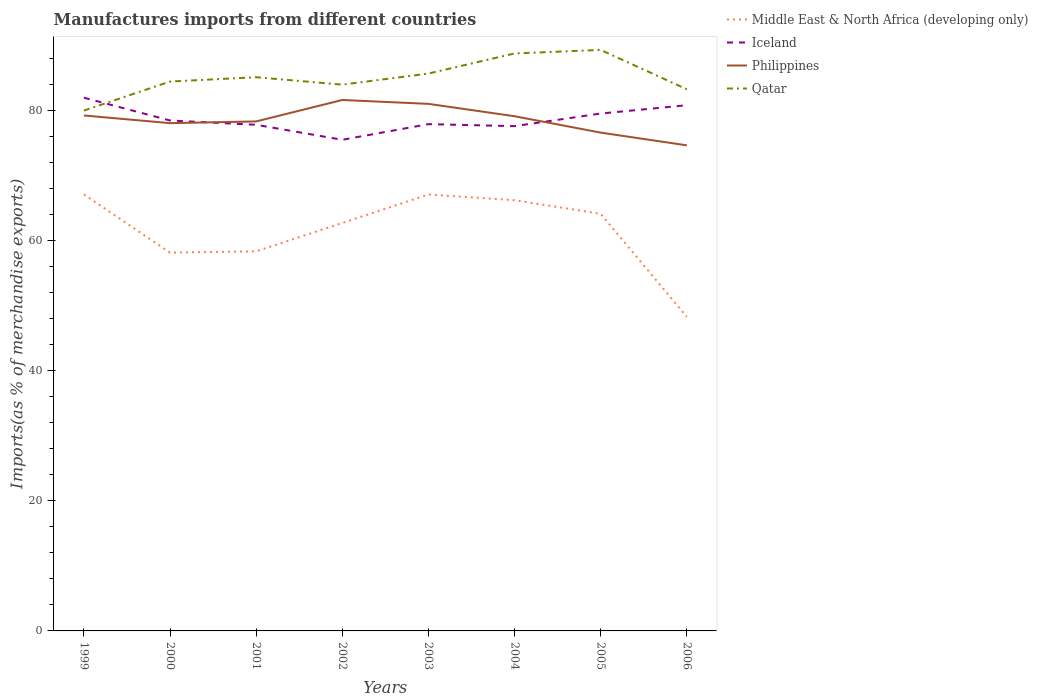Does the line corresponding to Iceland intersect with the line corresponding to Qatar?
Your answer should be compact. Yes. Is the number of lines equal to the number of legend labels?
Keep it short and to the point. Yes. Across all years, what is the maximum percentage of imports to different countries in Qatar?
Keep it short and to the point. 79.95. In which year was the percentage of imports to different countries in Philippines maximum?
Offer a very short reply. 2006. What is the total percentage of imports to different countries in Philippines in the graph?
Offer a very short reply. 4.59. What is the difference between the highest and the second highest percentage of imports to different countries in Philippines?
Your answer should be very brief. 6.97. Is the percentage of imports to different countries in Middle East & North Africa (developing only) strictly greater than the percentage of imports to different countries in Iceland over the years?
Offer a terse response. Yes. What is the difference between two consecutive major ticks on the Y-axis?
Make the answer very short. 20. Does the graph contain grids?
Offer a terse response. No. Where does the legend appear in the graph?
Your answer should be very brief. Top right. How are the legend labels stacked?
Make the answer very short. Vertical. What is the title of the graph?
Provide a succinct answer. Manufactures imports from different countries. Does "Central African Republic" appear as one of the legend labels in the graph?
Your answer should be very brief. No. What is the label or title of the Y-axis?
Your answer should be very brief. Imports(as % of merchandise exports). What is the Imports(as % of merchandise exports) of Middle East & North Africa (developing only) in 1999?
Ensure brevity in your answer.  67.07. What is the Imports(as % of merchandise exports) of Iceland in 1999?
Your answer should be compact. 81.93. What is the Imports(as % of merchandise exports) of Philippines in 1999?
Give a very brief answer. 79.2. What is the Imports(as % of merchandise exports) of Qatar in 1999?
Give a very brief answer. 79.95. What is the Imports(as % of merchandise exports) in Middle East & North Africa (developing only) in 2000?
Keep it short and to the point. 58.12. What is the Imports(as % of merchandise exports) in Iceland in 2000?
Provide a short and direct response. 78.42. What is the Imports(as % of merchandise exports) of Philippines in 2000?
Keep it short and to the point. 78.01. What is the Imports(as % of merchandise exports) in Qatar in 2000?
Provide a succinct answer. 84.41. What is the Imports(as % of merchandise exports) of Middle East & North Africa (developing only) in 2001?
Your answer should be compact. 58.32. What is the Imports(as % of merchandise exports) of Iceland in 2001?
Your answer should be compact. 77.76. What is the Imports(as % of merchandise exports) of Philippines in 2001?
Offer a very short reply. 78.28. What is the Imports(as % of merchandise exports) in Qatar in 2001?
Offer a terse response. 85.07. What is the Imports(as % of merchandise exports) of Middle East & North Africa (developing only) in 2002?
Provide a short and direct response. 62.68. What is the Imports(as % of merchandise exports) in Iceland in 2002?
Make the answer very short. 75.46. What is the Imports(as % of merchandise exports) in Philippines in 2002?
Offer a terse response. 81.57. What is the Imports(as % of merchandise exports) in Qatar in 2002?
Your response must be concise. 83.93. What is the Imports(as % of merchandise exports) in Middle East & North Africa (developing only) in 2003?
Ensure brevity in your answer.  67.05. What is the Imports(as % of merchandise exports) in Iceland in 2003?
Keep it short and to the point. 77.86. What is the Imports(as % of merchandise exports) of Philippines in 2003?
Offer a terse response. 80.98. What is the Imports(as % of merchandise exports) of Qatar in 2003?
Ensure brevity in your answer.  85.64. What is the Imports(as % of merchandise exports) in Middle East & North Africa (developing only) in 2004?
Provide a short and direct response. 66.18. What is the Imports(as % of merchandise exports) in Iceland in 2004?
Ensure brevity in your answer.  77.56. What is the Imports(as % of merchandise exports) of Philippines in 2004?
Keep it short and to the point. 79.07. What is the Imports(as % of merchandise exports) in Qatar in 2004?
Offer a very short reply. 88.72. What is the Imports(as % of merchandise exports) in Middle East & North Africa (developing only) in 2005?
Provide a succinct answer. 64.08. What is the Imports(as % of merchandise exports) in Iceland in 2005?
Give a very brief answer. 79.49. What is the Imports(as % of merchandise exports) of Philippines in 2005?
Your answer should be very brief. 76.56. What is the Imports(as % of merchandise exports) of Qatar in 2005?
Your response must be concise. 89.27. What is the Imports(as % of merchandise exports) of Middle East & North Africa (developing only) in 2006?
Ensure brevity in your answer.  48.25. What is the Imports(as % of merchandise exports) in Iceland in 2006?
Your answer should be very brief. 80.77. What is the Imports(as % of merchandise exports) in Philippines in 2006?
Your answer should be very brief. 74.6. What is the Imports(as % of merchandise exports) in Qatar in 2006?
Make the answer very short. 83.21. Across all years, what is the maximum Imports(as % of merchandise exports) in Middle East & North Africa (developing only)?
Your answer should be very brief. 67.07. Across all years, what is the maximum Imports(as % of merchandise exports) of Iceland?
Provide a short and direct response. 81.93. Across all years, what is the maximum Imports(as % of merchandise exports) of Philippines?
Provide a short and direct response. 81.57. Across all years, what is the maximum Imports(as % of merchandise exports) in Qatar?
Give a very brief answer. 89.27. Across all years, what is the minimum Imports(as % of merchandise exports) of Middle East & North Africa (developing only)?
Offer a very short reply. 48.25. Across all years, what is the minimum Imports(as % of merchandise exports) in Iceland?
Keep it short and to the point. 75.46. Across all years, what is the minimum Imports(as % of merchandise exports) of Philippines?
Your response must be concise. 74.6. Across all years, what is the minimum Imports(as % of merchandise exports) in Qatar?
Keep it short and to the point. 79.95. What is the total Imports(as % of merchandise exports) in Middle East & North Africa (developing only) in the graph?
Give a very brief answer. 491.75. What is the total Imports(as % of merchandise exports) in Iceland in the graph?
Your answer should be compact. 629.25. What is the total Imports(as % of merchandise exports) in Philippines in the graph?
Your answer should be compact. 628.28. What is the total Imports(as % of merchandise exports) in Qatar in the graph?
Ensure brevity in your answer.  680.19. What is the difference between the Imports(as % of merchandise exports) of Middle East & North Africa (developing only) in 1999 and that in 2000?
Provide a short and direct response. 8.95. What is the difference between the Imports(as % of merchandise exports) in Iceland in 1999 and that in 2000?
Make the answer very short. 3.5. What is the difference between the Imports(as % of merchandise exports) in Philippines in 1999 and that in 2000?
Ensure brevity in your answer.  1.18. What is the difference between the Imports(as % of merchandise exports) in Qatar in 1999 and that in 2000?
Keep it short and to the point. -4.46. What is the difference between the Imports(as % of merchandise exports) of Middle East & North Africa (developing only) in 1999 and that in 2001?
Your answer should be very brief. 8.75. What is the difference between the Imports(as % of merchandise exports) in Iceland in 1999 and that in 2001?
Give a very brief answer. 4.16. What is the difference between the Imports(as % of merchandise exports) in Philippines in 1999 and that in 2001?
Ensure brevity in your answer.  0.92. What is the difference between the Imports(as % of merchandise exports) in Qatar in 1999 and that in 2001?
Provide a short and direct response. -5.13. What is the difference between the Imports(as % of merchandise exports) of Middle East & North Africa (developing only) in 1999 and that in 2002?
Offer a terse response. 4.4. What is the difference between the Imports(as % of merchandise exports) in Iceland in 1999 and that in 2002?
Your answer should be compact. 6.47. What is the difference between the Imports(as % of merchandise exports) of Philippines in 1999 and that in 2002?
Provide a succinct answer. -2.38. What is the difference between the Imports(as % of merchandise exports) in Qatar in 1999 and that in 2002?
Keep it short and to the point. -3.99. What is the difference between the Imports(as % of merchandise exports) in Middle East & North Africa (developing only) in 1999 and that in 2003?
Provide a succinct answer. 0.02. What is the difference between the Imports(as % of merchandise exports) of Iceland in 1999 and that in 2003?
Keep it short and to the point. 4.07. What is the difference between the Imports(as % of merchandise exports) of Philippines in 1999 and that in 2003?
Give a very brief answer. -1.78. What is the difference between the Imports(as % of merchandise exports) of Qatar in 1999 and that in 2003?
Your answer should be compact. -5.69. What is the difference between the Imports(as % of merchandise exports) in Middle East & North Africa (developing only) in 1999 and that in 2004?
Offer a very short reply. 0.89. What is the difference between the Imports(as % of merchandise exports) in Iceland in 1999 and that in 2004?
Your answer should be very brief. 4.37. What is the difference between the Imports(as % of merchandise exports) in Philippines in 1999 and that in 2004?
Keep it short and to the point. 0.12. What is the difference between the Imports(as % of merchandise exports) of Qatar in 1999 and that in 2004?
Provide a succinct answer. -8.78. What is the difference between the Imports(as % of merchandise exports) in Middle East & North Africa (developing only) in 1999 and that in 2005?
Your response must be concise. 2.99. What is the difference between the Imports(as % of merchandise exports) of Iceland in 1999 and that in 2005?
Offer a terse response. 2.44. What is the difference between the Imports(as % of merchandise exports) of Philippines in 1999 and that in 2005?
Ensure brevity in your answer.  2.64. What is the difference between the Imports(as % of merchandise exports) of Qatar in 1999 and that in 2005?
Keep it short and to the point. -9.32. What is the difference between the Imports(as % of merchandise exports) in Middle East & North Africa (developing only) in 1999 and that in 2006?
Provide a short and direct response. 18.82. What is the difference between the Imports(as % of merchandise exports) of Iceland in 1999 and that in 2006?
Provide a short and direct response. 1.16. What is the difference between the Imports(as % of merchandise exports) of Philippines in 1999 and that in 2006?
Provide a succinct answer. 4.59. What is the difference between the Imports(as % of merchandise exports) in Qatar in 1999 and that in 2006?
Provide a succinct answer. -3.27. What is the difference between the Imports(as % of merchandise exports) in Middle East & North Africa (developing only) in 2000 and that in 2001?
Offer a very short reply. -0.2. What is the difference between the Imports(as % of merchandise exports) in Iceland in 2000 and that in 2001?
Offer a terse response. 0.66. What is the difference between the Imports(as % of merchandise exports) of Philippines in 2000 and that in 2001?
Offer a terse response. -0.27. What is the difference between the Imports(as % of merchandise exports) of Qatar in 2000 and that in 2001?
Offer a very short reply. -0.67. What is the difference between the Imports(as % of merchandise exports) in Middle East & North Africa (developing only) in 2000 and that in 2002?
Your answer should be compact. -4.56. What is the difference between the Imports(as % of merchandise exports) in Iceland in 2000 and that in 2002?
Your answer should be very brief. 2.97. What is the difference between the Imports(as % of merchandise exports) of Philippines in 2000 and that in 2002?
Your answer should be very brief. -3.56. What is the difference between the Imports(as % of merchandise exports) of Qatar in 2000 and that in 2002?
Give a very brief answer. 0.48. What is the difference between the Imports(as % of merchandise exports) in Middle East & North Africa (developing only) in 2000 and that in 2003?
Ensure brevity in your answer.  -8.93. What is the difference between the Imports(as % of merchandise exports) in Iceland in 2000 and that in 2003?
Provide a succinct answer. 0.56. What is the difference between the Imports(as % of merchandise exports) of Philippines in 2000 and that in 2003?
Ensure brevity in your answer.  -2.97. What is the difference between the Imports(as % of merchandise exports) in Qatar in 2000 and that in 2003?
Make the answer very short. -1.23. What is the difference between the Imports(as % of merchandise exports) of Middle East & North Africa (developing only) in 2000 and that in 2004?
Make the answer very short. -8.06. What is the difference between the Imports(as % of merchandise exports) of Iceland in 2000 and that in 2004?
Your answer should be very brief. 0.87. What is the difference between the Imports(as % of merchandise exports) in Philippines in 2000 and that in 2004?
Ensure brevity in your answer.  -1.06. What is the difference between the Imports(as % of merchandise exports) in Qatar in 2000 and that in 2004?
Your answer should be very brief. -4.32. What is the difference between the Imports(as % of merchandise exports) of Middle East & North Africa (developing only) in 2000 and that in 2005?
Your answer should be very brief. -5.96. What is the difference between the Imports(as % of merchandise exports) in Iceland in 2000 and that in 2005?
Keep it short and to the point. -1.07. What is the difference between the Imports(as % of merchandise exports) of Philippines in 2000 and that in 2005?
Your answer should be compact. 1.45. What is the difference between the Imports(as % of merchandise exports) of Qatar in 2000 and that in 2005?
Your answer should be compact. -4.86. What is the difference between the Imports(as % of merchandise exports) in Middle East & North Africa (developing only) in 2000 and that in 2006?
Offer a terse response. 9.87. What is the difference between the Imports(as % of merchandise exports) in Iceland in 2000 and that in 2006?
Give a very brief answer. -2.35. What is the difference between the Imports(as % of merchandise exports) of Philippines in 2000 and that in 2006?
Your response must be concise. 3.41. What is the difference between the Imports(as % of merchandise exports) in Qatar in 2000 and that in 2006?
Your answer should be very brief. 1.19. What is the difference between the Imports(as % of merchandise exports) of Middle East & North Africa (developing only) in 2001 and that in 2002?
Give a very brief answer. -4.35. What is the difference between the Imports(as % of merchandise exports) of Iceland in 2001 and that in 2002?
Your response must be concise. 2.3. What is the difference between the Imports(as % of merchandise exports) in Philippines in 2001 and that in 2002?
Give a very brief answer. -3.29. What is the difference between the Imports(as % of merchandise exports) of Qatar in 2001 and that in 2002?
Provide a succinct answer. 1.14. What is the difference between the Imports(as % of merchandise exports) of Middle East & North Africa (developing only) in 2001 and that in 2003?
Offer a very short reply. -8.73. What is the difference between the Imports(as % of merchandise exports) in Iceland in 2001 and that in 2003?
Offer a terse response. -0.1. What is the difference between the Imports(as % of merchandise exports) in Philippines in 2001 and that in 2003?
Provide a short and direct response. -2.7. What is the difference between the Imports(as % of merchandise exports) of Qatar in 2001 and that in 2003?
Provide a short and direct response. -0.56. What is the difference between the Imports(as % of merchandise exports) of Middle East & North Africa (developing only) in 2001 and that in 2004?
Your answer should be compact. -7.86. What is the difference between the Imports(as % of merchandise exports) in Iceland in 2001 and that in 2004?
Keep it short and to the point. 0.21. What is the difference between the Imports(as % of merchandise exports) of Philippines in 2001 and that in 2004?
Your response must be concise. -0.79. What is the difference between the Imports(as % of merchandise exports) of Qatar in 2001 and that in 2004?
Offer a very short reply. -3.65. What is the difference between the Imports(as % of merchandise exports) in Middle East & North Africa (developing only) in 2001 and that in 2005?
Your answer should be compact. -5.76. What is the difference between the Imports(as % of merchandise exports) in Iceland in 2001 and that in 2005?
Your response must be concise. -1.73. What is the difference between the Imports(as % of merchandise exports) of Philippines in 2001 and that in 2005?
Provide a short and direct response. 1.72. What is the difference between the Imports(as % of merchandise exports) of Qatar in 2001 and that in 2005?
Offer a terse response. -4.19. What is the difference between the Imports(as % of merchandise exports) of Middle East & North Africa (developing only) in 2001 and that in 2006?
Give a very brief answer. 10.07. What is the difference between the Imports(as % of merchandise exports) in Iceland in 2001 and that in 2006?
Your response must be concise. -3.01. What is the difference between the Imports(as % of merchandise exports) in Philippines in 2001 and that in 2006?
Make the answer very short. 3.68. What is the difference between the Imports(as % of merchandise exports) of Qatar in 2001 and that in 2006?
Offer a very short reply. 1.86. What is the difference between the Imports(as % of merchandise exports) in Middle East & North Africa (developing only) in 2002 and that in 2003?
Make the answer very short. -4.37. What is the difference between the Imports(as % of merchandise exports) in Iceland in 2002 and that in 2003?
Keep it short and to the point. -2.4. What is the difference between the Imports(as % of merchandise exports) in Philippines in 2002 and that in 2003?
Keep it short and to the point. 0.59. What is the difference between the Imports(as % of merchandise exports) of Qatar in 2002 and that in 2003?
Your answer should be very brief. -1.7. What is the difference between the Imports(as % of merchandise exports) in Middle East & North Africa (developing only) in 2002 and that in 2004?
Make the answer very short. -3.5. What is the difference between the Imports(as % of merchandise exports) of Iceland in 2002 and that in 2004?
Offer a very short reply. -2.1. What is the difference between the Imports(as % of merchandise exports) of Philippines in 2002 and that in 2004?
Your answer should be compact. 2.5. What is the difference between the Imports(as % of merchandise exports) in Qatar in 2002 and that in 2004?
Your answer should be very brief. -4.79. What is the difference between the Imports(as % of merchandise exports) in Middle East & North Africa (developing only) in 2002 and that in 2005?
Provide a succinct answer. -1.41. What is the difference between the Imports(as % of merchandise exports) of Iceland in 2002 and that in 2005?
Your answer should be compact. -4.03. What is the difference between the Imports(as % of merchandise exports) of Philippines in 2002 and that in 2005?
Provide a short and direct response. 5.01. What is the difference between the Imports(as % of merchandise exports) in Qatar in 2002 and that in 2005?
Ensure brevity in your answer.  -5.33. What is the difference between the Imports(as % of merchandise exports) in Middle East & North Africa (developing only) in 2002 and that in 2006?
Keep it short and to the point. 14.42. What is the difference between the Imports(as % of merchandise exports) of Iceland in 2002 and that in 2006?
Offer a very short reply. -5.31. What is the difference between the Imports(as % of merchandise exports) in Philippines in 2002 and that in 2006?
Offer a terse response. 6.97. What is the difference between the Imports(as % of merchandise exports) in Qatar in 2002 and that in 2006?
Your answer should be compact. 0.72. What is the difference between the Imports(as % of merchandise exports) in Middle East & North Africa (developing only) in 2003 and that in 2004?
Your answer should be very brief. 0.87. What is the difference between the Imports(as % of merchandise exports) of Iceland in 2003 and that in 2004?
Your response must be concise. 0.31. What is the difference between the Imports(as % of merchandise exports) of Philippines in 2003 and that in 2004?
Your answer should be compact. 1.9. What is the difference between the Imports(as % of merchandise exports) of Qatar in 2003 and that in 2004?
Keep it short and to the point. -3.09. What is the difference between the Imports(as % of merchandise exports) of Middle East & North Africa (developing only) in 2003 and that in 2005?
Your answer should be compact. 2.97. What is the difference between the Imports(as % of merchandise exports) in Iceland in 2003 and that in 2005?
Ensure brevity in your answer.  -1.63. What is the difference between the Imports(as % of merchandise exports) in Philippines in 2003 and that in 2005?
Make the answer very short. 4.42. What is the difference between the Imports(as % of merchandise exports) in Qatar in 2003 and that in 2005?
Keep it short and to the point. -3.63. What is the difference between the Imports(as % of merchandise exports) of Middle East & North Africa (developing only) in 2003 and that in 2006?
Provide a succinct answer. 18.8. What is the difference between the Imports(as % of merchandise exports) of Iceland in 2003 and that in 2006?
Your response must be concise. -2.91. What is the difference between the Imports(as % of merchandise exports) of Philippines in 2003 and that in 2006?
Make the answer very short. 6.37. What is the difference between the Imports(as % of merchandise exports) of Qatar in 2003 and that in 2006?
Provide a short and direct response. 2.42. What is the difference between the Imports(as % of merchandise exports) in Middle East & North Africa (developing only) in 2004 and that in 2005?
Make the answer very short. 2.1. What is the difference between the Imports(as % of merchandise exports) of Iceland in 2004 and that in 2005?
Offer a very short reply. -1.94. What is the difference between the Imports(as % of merchandise exports) in Philippines in 2004 and that in 2005?
Give a very brief answer. 2.51. What is the difference between the Imports(as % of merchandise exports) of Qatar in 2004 and that in 2005?
Make the answer very short. -0.54. What is the difference between the Imports(as % of merchandise exports) of Middle East & North Africa (developing only) in 2004 and that in 2006?
Your response must be concise. 17.92. What is the difference between the Imports(as % of merchandise exports) of Iceland in 2004 and that in 2006?
Ensure brevity in your answer.  -3.21. What is the difference between the Imports(as % of merchandise exports) in Philippines in 2004 and that in 2006?
Your answer should be very brief. 4.47. What is the difference between the Imports(as % of merchandise exports) of Qatar in 2004 and that in 2006?
Give a very brief answer. 5.51. What is the difference between the Imports(as % of merchandise exports) in Middle East & North Africa (developing only) in 2005 and that in 2006?
Your answer should be very brief. 15.83. What is the difference between the Imports(as % of merchandise exports) in Iceland in 2005 and that in 2006?
Give a very brief answer. -1.28. What is the difference between the Imports(as % of merchandise exports) of Philippines in 2005 and that in 2006?
Your response must be concise. 1.96. What is the difference between the Imports(as % of merchandise exports) in Qatar in 2005 and that in 2006?
Provide a short and direct response. 6.05. What is the difference between the Imports(as % of merchandise exports) in Middle East & North Africa (developing only) in 1999 and the Imports(as % of merchandise exports) in Iceland in 2000?
Your answer should be compact. -11.35. What is the difference between the Imports(as % of merchandise exports) in Middle East & North Africa (developing only) in 1999 and the Imports(as % of merchandise exports) in Philippines in 2000?
Provide a short and direct response. -10.94. What is the difference between the Imports(as % of merchandise exports) in Middle East & North Africa (developing only) in 1999 and the Imports(as % of merchandise exports) in Qatar in 2000?
Provide a short and direct response. -17.33. What is the difference between the Imports(as % of merchandise exports) in Iceland in 1999 and the Imports(as % of merchandise exports) in Philippines in 2000?
Offer a terse response. 3.91. What is the difference between the Imports(as % of merchandise exports) in Iceland in 1999 and the Imports(as % of merchandise exports) in Qatar in 2000?
Give a very brief answer. -2.48. What is the difference between the Imports(as % of merchandise exports) of Philippines in 1999 and the Imports(as % of merchandise exports) of Qatar in 2000?
Provide a succinct answer. -5.21. What is the difference between the Imports(as % of merchandise exports) in Middle East & North Africa (developing only) in 1999 and the Imports(as % of merchandise exports) in Iceland in 2001?
Your answer should be very brief. -10.69. What is the difference between the Imports(as % of merchandise exports) of Middle East & North Africa (developing only) in 1999 and the Imports(as % of merchandise exports) of Philippines in 2001?
Make the answer very short. -11.21. What is the difference between the Imports(as % of merchandise exports) in Middle East & North Africa (developing only) in 1999 and the Imports(as % of merchandise exports) in Qatar in 2001?
Your answer should be very brief. -18. What is the difference between the Imports(as % of merchandise exports) in Iceland in 1999 and the Imports(as % of merchandise exports) in Philippines in 2001?
Make the answer very short. 3.65. What is the difference between the Imports(as % of merchandise exports) of Iceland in 1999 and the Imports(as % of merchandise exports) of Qatar in 2001?
Offer a terse response. -3.14. What is the difference between the Imports(as % of merchandise exports) of Philippines in 1999 and the Imports(as % of merchandise exports) of Qatar in 2001?
Provide a short and direct response. -5.88. What is the difference between the Imports(as % of merchandise exports) of Middle East & North Africa (developing only) in 1999 and the Imports(as % of merchandise exports) of Iceland in 2002?
Make the answer very short. -8.39. What is the difference between the Imports(as % of merchandise exports) in Middle East & North Africa (developing only) in 1999 and the Imports(as % of merchandise exports) in Philippines in 2002?
Your answer should be very brief. -14.5. What is the difference between the Imports(as % of merchandise exports) of Middle East & North Africa (developing only) in 1999 and the Imports(as % of merchandise exports) of Qatar in 2002?
Your response must be concise. -16.86. What is the difference between the Imports(as % of merchandise exports) of Iceland in 1999 and the Imports(as % of merchandise exports) of Philippines in 2002?
Provide a succinct answer. 0.35. What is the difference between the Imports(as % of merchandise exports) in Iceland in 1999 and the Imports(as % of merchandise exports) in Qatar in 2002?
Keep it short and to the point. -2. What is the difference between the Imports(as % of merchandise exports) of Philippines in 1999 and the Imports(as % of merchandise exports) of Qatar in 2002?
Provide a succinct answer. -4.73. What is the difference between the Imports(as % of merchandise exports) in Middle East & North Africa (developing only) in 1999 and the Imports(as % of merchandise exports) in Iceland in 2003?
Your response must be concise. -10.79. What is the difference between the Imports(as % of merchandise exports) of Middle East & North Africa (developing only) in 1999 and the Imports(as % of merchandise exports) of Philippines in 2003?
Your answer should be compact. -13.91. What is the difference between the Imports(as % of merchandise exports) in Middle East & North Africa (developing only) in 1999 and the Imports(as % of merchandise exports) in Qatar in 2003?
Offer a very short reply. -18.56. What is the difference between the Imports(as % of merchandise exports) of Iceland in 1999 and the Imports(as % of merchandise exports) of Philippines in 2003?
Give a very brief answer. 0.95. What is the difference between the Imports(as % of merchandise exports) in Iceland in 1999 and the Imports(as % of merchandise exports) in Qatar in 2003?
Provide a short and direct response. -3.71. What is the difference between the Imports(as % of merchandise exports) in Philippines in 1999 and the Imports(as % of merchandise exports) in Qatar in 2003?
Make the answer very short. -6.44. What is the difference between the Imports(as % of merchandise exports) of Middle East & North Africa (developing only) in 1999 and the Imports(as % of merchandise exports) of Iceland in 2004?
Offer a terse response. -10.48. What is the difference between the Imports(as % of merchandise exports) of Middle East & North Africa (developing only) in 1999 and the Imports(as % of merchandise exports) of Philippines in 2004?
Your answer should be very brief. -12. What is the difference between the Imports(as % of merchandise exports) in Middle East & North Africa (developing only) in 1999 and the Imports(as % of merchandise exports) in Qatar in 2004?
Give a very brief answer. -21.65. What is the difference between the Imports(as % of merchandise exports) of Iceland in 1999 and the Imports(as % of merchandise exports) of Philippines in 2004?
Ensure brevity in your answer.  2.85. What is the difference between the Imports(as % of merchandise exports) in Iceland in 1999 and the Imports(as % of merchandise exports) in Qatar in 2004?
Provide a short and direct response. -6.79. What is the difference between the Imports(as % of merchandise exports) in Philippines in 1999 and the Imports(as % of merchandise exports) in Qatar in 2004?
Ensure brevity in your answer.  -9.53. What is the difference between the Imports(as % of merchandise exports) in Middle East & North Africa (developing only) in 1999 and the Imports(as % of merchandise exports) in Iceland in 2005?
Your answer should be very brief. -12.42. What is the difference between the Imports(as % of merchandise exports) in Middle East & North Africa (developing only) in 1999 and the Imports(as % of merchandise exports) in Philippines in 2005?
Keep it short and to the point. -9.49. What is the difference between the Imports(as % of merchandise exports) of Middle East & North Africa (developing only) in 1999 and the Imports(as % of merchandise exports) of Qatar in 2005?
Your response must be concise. -22.19. What is the difference between the Imports(as % of merchandise exports) of Iceland in 1999 and the Imports(as % of merchandise exports) of Philippines in 2005?
Provide a succinct answer. 5.37. What is the difference between the Imports(as % of merchandise exports) of Iceland in 1999 and the Imports(as % of merchandise exports) of Qatar in 2005?
Make the answer very short. -7.34. What is the difference between the Imports(as % of merchandise exports) in Philippines in 1999 and the Imports(as % of merchandise exports) in Qatar in 2005?
Offer a terse response. -10.07. What is the difference between the Imports(as % of merchandise exports) in Middle East & North Africa (developing only) in 1999 and the Imports(as % of merchandise exports) in Iceland in 2006?
Ensure brevity in your answer.  -13.7. What is the difference between the Imports(as % of merchandise exports) in Middle East & North Africa (developing only) in 1999 and the Imports(as % of merchandise exports) in Philippines in 2006?
Offer a very short reply. -7.53. What is the difference between the Imports(as % of merchandise exports) of Middle East & North Africa (developing only) in 1999 and the Imports(as % of merchandise exports) of Qatar in 2006?
Your answer should be very brief. -16.14. What is the difference between the Imports(as % of merchandise exports) in Iceland in 1999 and the Imports(as % of merchandise exports) in Philippines in 2006?
Give a very brief answer. 7.32. What is the difference between the Imports(as % of merchandise exports) in Iceland in 1999 and the Imports(as % of merchandise exports) in Qatar in 2006?
Provide a short and direct response. -1.29. What is the difference between the Imports(as % of merchandise exports) in Philippines in 1999 and the Imports(as % of merchandise exports) in Qatar in 2006?
Make the answer very short. -4.02. What is the difference between the Imports(as % of merchandise exports) of Middle East & North Africa (developing only) in 2000 and the Imports(as % of merchandise exports) of Iceland in 2001?
Provide a short and direct response. -19.64. What is the difference between the Imports(as % of merchandise exports) of Middle East & North Africa (developing only) in 2000 and the Imports(as % of merchandise exports) of Philippines in 2001?
Offer a terse response. -20.16. What is the difference between the Imports(as % of merchandise exports) in Middle East & North Africa (developing only) in 2000 and the Imports(as % of merchandise exports) in Qatar in 2001?
Ensure brevity in your answer.  -26.95. What is the difference between the Imports(as % of merchandise exports) of Iceland in 2000 and the Imports(as % of merchandise exports) of Philippines in 2001?
Ensure brevity in your answer.  0.14. What is the difference between the Imports(as % of merchandise exports) of Iceland in 2000 and the Imports(as % of merchandise exports) of Qatar in 2001?
Ensure brevity in your answer.  -6.65. What is the difference between the Imports(as % of merchandise exports) of Philippines in 2000 and the Imports(as % of merchandise exports) of Qatar in 2001?
Provide a short and direct response. -7.06. What is the difference between the Imports(as % of merchandise exports) in Middle East & North Africa (developing only) in 2000 and the Imports(as % of merchandise exports) in Iceland in 2002?
Ensure brevity in your answer.  -17.34. What is the difference between the Imports(as % of merchandise exports) in Middle East & North Africa (developing only) in 2000 and the Imports(as % of merchandise exports) in Philippines in 2002?
Your response must be concise. -23.45. What is the difference between the Imports(as % of merchandise exports) in Middle East & North Africa (developing only) in 2000 and the Imports(as % of merchandise exports) in Qatar in 2002?
Keep it short and to the point. -25.81. What is the difference between the Imports(as % of merchandise exports) in Iceland in 2000 and the Imports(as % of merchandise exports) in Philippines in 2002?
Provide a short and direct response. -3.15. What is the difference between the Imports(as % of merchandise exports) in Iceland in 2000 and the Imports(as % of merchandise exports) in Qatar in 2002?
Provide a succinct answer. -5.51. What is the difference between the Imports(as % of merchandise exports) in Philippines in 2000 and the Imports(as % of merchandise exports) in Qatar in 2002?
Your answer should be very brief. -5.92. What is the difference between the Imports(as % of merchandise exports) in Middle East & North Africa (developing only) in 2000 and the Imports(as % of merchandise exports) in Iceland in 2003?
Make the answer very short. -19.74. What is the difference between the Imports(as % of merchandise exports) in Middle East & North Africa (developing only) in 2000 and the Imports(as % of merchandise exports) in Philippines in 2003?
Keep it short and to the point. -22.86. What is the difference between the Imports(as % of merchandise exports) in Middle East & North Africa (developing only) in 2000 and the Imports(as % of merchandise exports) in Qatar in 2003?
Your answer should be very brief. -27.52. What is the difference between the Imports(as % of merchandise exports) in Iceland in 2000 and the Imports(as % of merchandise exports) in Philippines in 2003?
Give a very brief answer. -2.56. What is the difference between the Imports(as % of merchandise exports) in Iceland in 2000 and the Imports(as % of merchandise exports) in Qatar in 2003?
Keep it short and to the point. -7.21. What is the difference between the Imports(as % of merchandise exports) in Philippines in 2000 and the Imports(as % of merchandise exports) in Qatar in 2003?
Give a very brief answer. -7.62. What is the difference between the Imports(as % of merchandise exports) of Middle East & North Africa (developing only) in 2000 and the Imports(as % of merchandise exports) of Iceland in 2004?
Keep it short and to the point. -19.43. What is the difference between the Imports(as % of merchandise exports) of Middle East & North Africa (developing only) in 2000 and the Imports(as % of merchandise exports) of Philippines in 2004?
Offer a very short reply. -20.95. What is the difference between the Imports(as % of merchandise exports) of Middle East & North Africa (developing only) in 2000 and the Imports(as % of merchandise exports) of Qatar in 2004?
Offer a terse response. -30.6. What is the difference between the Imports(as % of merchandise exports) of Iceland in 2000 and the Imports(as % of merchandise exports) of Philippines in 2004?
Make the answer very short. -0.65. What is the difference between the Imports(as % of merchandise exports) of Iceland in 2000 and the Imports(as % of merchandise exports) of Qatar in 2004?
Your answer should be compact. -10.3. What is the difference between the Imports(as % of merchandise exports) of Philippines in 2000 and the Imports(as % of merchandise exports) of Qatar in 2004?
Your answer should be very brief. -10.71. What is the difference between the Imports(as % of merchandise exports) in Middle East & North Africa (developing only) in 2000 and the Imports(as % of merchandise exports) in Iceland in 2005?
Keep it short and to the point. -21.37. What is the difference between the Imports(as % of merchandise exports) in Middle East & North Africa (developing only) in 2000 and the Imports(as % of merchandise exports) in Philippines in 2005?
Give a very brief answer. -18.44. What is the difference between the Imports(as % of merchandise exports) of Middle East & North Africa (developing only) in 2000 and the Imports(as % of merchandise exports) of Qatar in 2005?
Make the answer very short. -31.15. What is the difference between the Imports(as % of merchandise exports) of Iceland in 2000 and the Imports(as % of merchandise exports) of Philippines in 2005?
Give a very brief answer. 1.86. What is the difference between the Imports(as % of merchandise exports) of Iceland in 2000 and the Imports(as % of merchandise exports) of Qatar in 2005?
Ensure brevity in your answer.  -10.84. What is the difference between the Imports(as % of merchandise exports) in Philippines in 2000 and the Imports(as % of merchandise exports) in Qatar in 2005?
Your response must be concise. -11.25. What is the difference between the Imports(as % of merchandise exports) of Middle East & North Africa (developing only) in 2000 and the Imports(as % of merchandise exports) of Iceland in 2006?
Provide a short and direct response. -22.65. What is the difference between the Imports(as % of merchandise exports) in Middle East & North Africa (developing only) in 2000 and the Imports(as % of merchandise exports) in Philippines in 2006?
Ensure brevity in your answer.  -16.48. What is the difference between the Imports(as % of merchandise exports) in Middle East & North Africa (developing only) in 2000 and the Imports(as % of merchandise exports) in Qatar in 2006?
Offer a terse response. -25.09. What is the difference between the Imports(as % of merchandise exports) in Iceland in 2000 and the Imports(as % of merchandise exports) in Philippines in 2006?
Provide a succinct answer. 3.82. What is the difference between the Imports(as % of merchandise exports) in Iceland in 2000 and the Imports(as % of merchandise exports) in Qatar in 2006?
Make the answer very short. -4.79. What is the difference between the Imports(as % of merchandise exports) in Philippines in 2000 and the Imports(as % of merchandise exports) in Qatar in 2006?
Your answer should be very brief. -5.2. What is the difference between the Imports(as % of merchandise exports) in Middle East & North Africa (developing only) in 2001 and the Imports(as % of merchandise exports) in Iceland in 2002?
Offer a terse response. -17.14. What is the difference between the Imports(as % of merchandise exports) in Middle East & North Africa (developing only) in 2001 and the Imports(as % of merchandise exports) in Philippines in 2002?
Offer a very short reply. -23.25. What is the difference between the Imports(as % of merchandise exports) of Middle East & North Africa (developing only) in 2001 and the Imports(as % of merchandise exports) of Qatar in 2002?
Give a very brief answer. -25.61. What is the difference between the Imports(as % of merchandise exports) in Iceland in 2001 and the Imports(as % of merchandise exports) in Philippines in 2002?
Your answer should be very brief. -3.81. What is the difference between the Imports(as % of merchandise exports) in Iceland in 2001 and the Imports(as % of merchandise exports) in Qatar in 2002?
Give a very brief answer. -6.17. What is the difference between the Imports(as % of merchandise exports) of Philippines in 2001 and the Imports(as % of merchandise exports) of Qatar in 2002?
Keep it short and to the point. -5.65. What is the difference between the Imports(as % of merchandise exports) of Middle East & North Africa (developing only) in 2001 and the Imports(as % of merchandise exports) of Iceland in 2003?
Make the answer very short. -19.54. What is the difference between the Imports(as % of merchandise exports) of Middle East & North Africa (developing only) in 2001 and the Imports(as % of merchandise exports) of Philippines in 2003?
Provide a succinct answer. -22.66. What is the difference between the Imports(as % of merchandise exports) of Middle East & North Africa (developing only) in 2001 and the Imports(as % of merchandise exports) of Qatar in 2003?
Your answer should be very brief. -27.31. What is the difference between the Imports(as % of merchandise exports) in Iceland in 2001 and the Imports(as % of merchandise exports) in Philippines in 2003?
Your response must be concise. -3.22. What is the difference between the Imports(as % of merchandise exports) in Iceland in 2001 and the Imports(as % of merchandise exports) in Qatar in 2003?
Your answer should be very brief. -7.87. What is the difference between the Imports(as % of merchandise exports) of Philippines in 2001 and the Imports(as % of merchandise exports) of Qatar in 2003?
Provide a succinct answer. -7.35. What is the difference between the Imports(as % of merchandise exports) of Middle East & North Africa (developing only) in 2001 and the Imports(as % of merchandise exports) of Iceland in 2004?
Your response must be concise. -19.23. What is the difference between the Imports(as % of merchandise exports) in Middle East & North Africa (developing only) in 2001 and the Imports(as % of merchandise exports) in Philippines in 2004?
Your answer should be very brief. -20.75. What is the difference between the Imports(as % of merchandise exports) of Middle East & North Africa (developing only) in 2001 and the Imports(as % of merchandise exports) of Qatar in 2004?
Your answer should be compact. -30.4. What is the difference between the Imports(as % of merchandise exports) in Iceland in 2001 and the Imports(as % of merchandise exports) in Philippines in 2004?
Your answer should be very brief. -1.31. What is the difference between the Imports(as % of merchandise exports) in Iceland in 2001 and the Imports(as % of merchandise exports) in Qatar in 2004?
Your answer should be compact. -10.96. What is the difference between the Imports(as % of merchandise exports) in Philippines in 2001 and the Imports(as % of merchandise exports) in Qatar in 2004?
Give a very brief answer. -10.44. What is the difference between the Imports(as % of merchandise exports) in Middle East & North Africa (developing only) in 2001 and the Imports(as % of merchandise exports) in Iceland in 2005?
Make the answer very short. -21.17. What is the difference between the Imports(as % of merchandise exports) of Middle East & North Africa (developing only) in 2001 and the Imports(as % of merchandise exports) of Philippines in 2005?
Make the answer very short. -18.24. What is the difference between the Imports(as % of merchandise exports) of Middle East & North Africa (developing only) in 2001 and the Imports(as % of merchandise exports) of Qatar in 2005?
Your response must be concise. -30.94. What is the difference between the Imports(as % of merchandise exports) of Iceland in 2001 and the Imports(as % of merchandise exports) of Philippines in 2005?
Offer a very short reply. 1.2. What is the difference between the Imports(as % of merchandise exports) in Iceland in 2001 and the Imports(as % of merchandise exports) in Qatar in 2005?
Keep it short and to the point. -11.5. What is the difference between the Imports(as % of merchandise exports) of Philippines in 2001 and the Imports(as % of merchandise exports) of Qatar in 2005?
Offer a very short reply. -10.98. What is the difference between the Imports(as % of merchandise exports) in Middle East & North Africa (developing only) in 2001 and the Imports(as % of merchandise exports) in Iceland in 2006?
Make the answer very short. -22.45. What is the difference between the Imports(as % of merchandise exports) in Middle East & North Africa (developing only) in 2001 and the Imports(as % of merchandise exports) in Philippines in 2006?
Provide a succinct answer. -16.28. What is the difference between the Imports(as % of merchandise exports) of Middle East & North Africa (developing only) in 2001 and the Imports(as % of merchandise exports) of Qatar in 2006?
Provide a short and direct response. -24.89. What is the difference between the Imports(as % of merchandise exports) in Iceland in 2001 and the Imports(as % of merchandise exports) in Philippines in 2006?
Provide a succinct answer. 3.16. What is the difference between the Imports(as % of merchandise exports) of Iceland in 2001 and the Imports(as % of merchandise exports) of Qatar in 2006?
Provide a short and direct response. -5.45. What is the difference between the Imports(as % of merchandise exports) in Philippines in 2001 and the Imports(as % of merchandise exports) in Qatar in 2006?
Provide a short and direct response. -4.93. What is the difference between the Imports(as % of merchandise exports) of Middle East & North Africa (developing only) in 2002 and the Imports(as % of merchandise exports) of Iceland in 2003?
Provide a succinct answer. -15.19. What is the difference between the Imports(as % of merchandise exports) of Middle East & North Africa (developing only) in 2002 and the Imports(as % of merchandise exports) of Philippines in 2003?
Give a very brief answer. -18.3. What is the difference between the Imports(as % of merchandise exports) of Middle East & North Africa (developing only) in 2002 and the Imports(as % of merchandise exports) of Qatar in 2003?
Make the answer very short. -22.96. What is the difference between the Imports(as % of merchandise exports) of Iceland in 2002 and the Imports(as % of merchandise exports) of Philippines in 2003?
Keep it short and to the point. -5.52. What is the difference between the Imports(as % of merchandise exports) in Iceland in 2002 and the Imports(as % of merchandise exports) in Qatar in 2003?
Provide a succinct answer. -10.18. What is the difference between the Imports(as % of merchandise exports) of Philippines in 2002 and the Imports(as % of merchandise exports) of Qatar in 2003?
Your answer should be very brief. -4.06. What is the difference between the Imports(as % of merchandise exports) of Middle East & North Africa (developing only) in 2002 and the Imports(as % of merchandise exports) of Iceland in 2004?
Keep it short and to the point. -14.88. What is the difference between the Imports(as % of merchandise exports) in Middle East & North Africa (developing only) in 2002 and the Imports(as % of merchandise exports) in Philippines in 2004?
Your answer should be very brief. -16.4. What is the difference between the Imports(as % of merchandise exports) of Middle East & North Africa (developing only) in 2002 and the Imports(as % of merchandise exports) of Qatar in 2004?
Your response must be concise. -26.05. What is the difference between the Imports(as % of merchandise exports) of Iceland in 2002 and the Imports(as % of merchandise exports) of Philippines in 2004?
Provide a succinct answer. -3.62. What is the difference between the Imports(as % of merchandise exports) of Iceland in 2002 and the Imports(as % of merchandise exports) of Qatar in 2004?
Provide a succinct answer. -13.26. What is the difference between the Imports(as % of merchandise exports) of Philippines in 2002 and the Imports(as % of merchandise exports) of Qatar in 2004?
Offer a very short reply. -7.15. What is the difference between the Imports(as % of merchandise exports) of Middle East & North Africa (developing only) in 2002 and the Imports(as % of merchandise exports) of Iceland in 2005?
Provide a short and direct response. -16.82. What is the difference between the Imports(as % of merchandise exports) of Middle East & North Africa (developing only) in 2002 and the Imports(as % of merchandise exports) of Philippines in 2005?
Ensure brevity in your answer.  -13.88. What is the difference between the Imports(as % of merchandise exports) of Middle East & North Africa (developing only) in 2002 and the Imports(as % of merchandise exports) of Qatar in 2005?
Provide a short and direct response. -26.59. What is the difference between the Imports(as % of merchandise exports) in Iceland in 2002 and the Imports(as % of merchandise exports) in Philippines in 2005?
Your response must be concise. -1.1. What is the difference between the Imports(as % of merchandise exports) in Iceland in 2002 and the Imports(as % of merchandise exports) in Qatar in 2005?
Ensure brevity in your answer.  -13.81. What is the difference between the Imports(as % of merchandise exports) in Philippines in 2002 and the Imports(as % of merchandise exports) in Qatar in 2005?
Give a very brief answer. -7.69. What is the difference between the Imports(as % of merchandise exports) of Middle East & North Africa (developing only) in 2002 and the Imports(as % of merchandise exports) of Iceland in 2006?
Provide a succinct answer. -18.09. What is the difference between the Imports(as % of merchandise exports) of Middle East & North Africa (developing only) in 2002 and the Imports(as % of merchandise exports) of Philippines in 2006?
Ensure brevity in your answer.  -11.93. What is the difference between the Imports(as % of merchandise exports) of Middle East & North Africa (developing only) in 2002 and the Imports(as % of merchandise exports) of Qatar in 2006?
Offer a very short reply. -20.54. What is the difference between the Imports(as % of merchandise exports) of Iceland in 2002 and the Imports(as % of merchandise exports) of Philippines in 2006?
Ensure brevity in your answer.  0.85. What is the difference between the Imports(as % of merchandise exports) of Iceland in 2002 and the Imports(as % of merchandise exports) of Qatar in 2006?
Your answer should be compact. -7.76. What is the difference between the Imports(as % of merchandise exports) of Philippines in 2002 and the Imports(as % of merchandise exports) of Qatar in 2006?
Keep it short and to the point. -1.64. What is the difference between the Imports(as % of merchandise exports) in Middle East & North Africa (developing only) in 2003 and the Imports(as % of merchandise exports) in Iceland in 2004?
Ensure brevity in your answer.  -10.51. What is the difference between the Imports(as % of merchandise exports) in Middle East & North Africa (developing only) in 2003 and the Imports(as % of merchandise exports) in Philippines in 2004?
Keep it short and to the point. -12.02. What is the difference between the Imports(as % of merchandise exports) in Middle East & North Africa (developing only) in 2003 and the Imports(as % of merchandise exports) in Qatar in 2004?
Your response must be concise. -21.67. What is the difference between the Imports(as % of merchandise exports) in Iceland in 2003 and the Imports(as % of merchandise exports) in Philippines in 2004?
Provide a succinct answer. -1.21. What is the difference between the Imports(as % of merchandise exports) of Iceland in 2003 and the Imports(as % of merchandise exports) of Qatar in 2004?
Offer a terse response. -10.86. What is the difference between the Imports(as % of merchandise exports) of Philippines in 2003 and the Imports(as % of merchandise exports) of Qatar in 2004?
Your answer should be compact. -7.74. What is the difference between the Imports(as % of merchandise exports) of Middle East & North Africa (developing only) in 2003 and the Imports(as % of merchandise exports) of Iceland in 2005?
Keep it short and to the point. -12.44. What is the difference between the Imports(as % of merchandise exports) of Middle East & North Africa (developing only) in 2003 and the Imports(as % of merchandise exports) of Philippines in 2005?
Offer a very short reply. -9.51. What is the difference between the Imports(as % of merchandise exports) in Middle East & North Africa (developing only) in 2003 and the Imports(as % of merchandise exports) in Qatar in 2005?
Keep it short and to the point. -22.22. What is the difference between the Imports(as % of merchandise exports) in Iceland in 2003 and the Imports(as % of merchandise exports) in Philippines in 2005?
Your answer should be compact. 1.3. What is the difference between the Imports(as % of merchandise exports) in Iceland in 2003 and the Imports(as % of merchandise exports) in Qatar in 2005?
Make the answer very short. -11.4. What is the difference between the Imports(as % of merchandise exports) in Philippines in 2003 and the Imports(as % of merchandise exports) in Qatar in 2005?
Your answer should be very brief. -8.29. What is the difference between the Imports(as % of merchandise exports) in Middle East & North Africa (developing only) in 2003 and the Imports(as % of merchandise exports) in Iceland in 2006?
Your answer should be very brief. -13.72. What is the difference between the Imports(as % of merchandise exports) of Middle East & North Africa (developing only) in 2003 and the Imports(as % of merchandise exports) of Philippines in 2006?
Ensure brevity in your answer.  -7.55. What is the difference between the Imports(as % of merchandise exports) in Middle East & North Africa (developing only) in 2003 and the Imports(as % of merchandise exports) in Qatar in 2006?
Ensure brevity in your answer.  -16.16. What is the difference between the Imports(as % of merchandise exports) of Iceland in 2003 and the Imports(as % of merchandise exports) of Philippines in 2006?
Your answer should be very brief. 3.26. What is the difference between the Imports(as % of merchandise exports) in Iceland in 2003 and the Imports(as % of merchandise exports) in Qatar in 2006?
Keep it short and to the point. -5.35. What is the difference between the Imports(as % of merchandise exports) in Philippines in 2003 and the Imports(as % of merchandise exports) in Qatar in 2006?
Keep it short and to the point. -2.24. What is the difference between the Imports(as % of merchandise exports) in Middle East & North Africa (developing only) in 2004 and the Imports(as % of merchandise exports) in Iceland in 2005?
Offer a terse response. -13.31. What is the difference between the Imports(as % of merchandise exports) of Middle East & North Africa (developing only) in 2004 and the Imports(as % of merchandise exports) of Philippines in 2005?
Provide a short and direct response. -10.38. What is the difference between the Imports(as % of merchandise exports) of Middle East & North Africa (developing only) in 2004 and the Imports(as % of merchandise exports) of Qatar in 2005?
Keep it short and to the point. -23.09. What is the difference between the Imports(as % of merchandise exports) of Iceland in 2004 and the Imports(as % of merchandise exports) of Philippines in 2005?
Make the answer very short. 1. What is the difference between the Imports(as % of merchandise exports) of Iceland in 2004 and the Imports(as % of merchandise exports) of Qatar in 2005?
Offer a terse response. -11.71. What is the difference between the Imports(as % of merchandise exports) in Philippines in 2004 and the Imports(as % of merchandise exports) in Qatar in 2005?
Provide a short and direct response. -10.19. What is the difference between the Imports(as % of merchandise exports) in Middle East & North Africa (developing only) in 2004 and the Imports(as % of merchandise exports) in Iceland in 2006?
Your response must be concise. -14.59. What is the difference between the Imports(as % of merchandise exports) of Middle East & North Africa (developing only) in 2004 and the Imports(as % of merchandise exports) of Philippines in 2006?
Provide a succinct answer. -8.43. What is the difference between the Imports(as % of merchandise exports) in Middle East & North Africa (developing only) in 2004 and the Imports(as % of merchandise exports) in Qatar in 2006?
Offer a terse response. -17.03. What is the difference between the Imports(as % of merchandise exports) of Iceland in 2004 and the Imports(as % of merchandise exports) of Philippines in 2006?
Provide a short and direct response. 2.95. What is the difference between the Imports(as % of merchandise exports) in Iceland in 2004 and the Imports(as % of merchandise exports) in Qatar in 2006?
Provide a short and direct response. -5.66. What is the difference between the Imports(as % of merchandise exports) in Philippines in 2004 and the Imports(as % of merchandise exports) in Qatar in 2006?
Provide a short and direct response. -4.14. What is the difference between the Imports(as % of merchandise exports) of Middle East & North Africa (developing only) in 2005 and the Imports(as % of merchandise exports) of Iceland in 2006?
Provide a short and direct response. -16.69. What is the difference between the Imports(as % of merchandise exports) of Middle East & North Africa (developing only) in 2005 and the Imports(as % of merchandise exports) of Philippines in 2006?
Give a very brief answer. -10.52. What is the difference between the Imports(as % of merchandise exports) in Middle East & North Africa (developing only) in 2005 and the Imports(as % of merchandise exports) in Qatar in 2006?
Provide a succinct answer. -19.13. What is the difference between the Imports(as % of merchandise exports) in Iceland in 2005 and the Imports(as % of merchandise exports) in Philippines in 2006?
Give a very brief answer. 4.89. What is the difference between the Imports(as % of merchandise exports) of Iceland in 2005 and the Imports(as % of merchandise exports) of Qatar in 2006?
Offer a very short reply. -3.72. What is the difference between the Imports(as % of merchandise exports) of Philippines in 2005 and the Imports(as % of merchandise exports) of Qatar in 2006?
Keep it short and to the point. -6.65. What is the average Imports(as % of merchandise exports) of Middle East & North Africa (developing only) per year?
Provide a short and direct response. 61.47. What is the average Imports(as % of merchandise exports) in Iceland per year?
Give a very brief answer. 78.66. What is the average Imports(as % of merchandise exports) of Philippines per year?
Your answer should be very brief. 78.54. What is the average Imports(as % of merchandise exports) of Qatar per year?
Give a very brief answer. 85.02. In the year 1999, what is the difference between the Imports(as % of merchandise exports) in Middle East & North Africa (developing only) and Imports(as % of merchandise exports) in Iceland?
Your answer should be compact. -14.86. In the year 1999, what is the difference between the Imports(as % of merchandise exports) in Middle East & North Africa (developing only) and Imports(as % of merchandise exports) in Philippines?
Ensure brevity in your answer.  -12.12. In the year 1999, what is the difference between the Imports(as % of merchandise exports) of Middle East & North Africa (developing only) and Imports(as % of merchandise exports) of Qatar?
Provide a succinct answer. -12.87. In the year 1999, what is the difference between the Imports(as % of merchandise exports) in Iceland and Imports(as % of merchandise exports) in Philippines?
Your answer should be very brief. 2.73. In the year 1999, what is the difference between the Imports(as % of merchandise exports) in Iceland and Imports(as % of merchandise exports) in Qatar?
Give a very brief answer. 1.98. In the year 1999, what is the difference between the Imports(as % of merchandise exports) in Philippines and Imports(as % of merchandise exports) in Qatar?
Provide a succinct answer. -0.75. In the year 2000, what is the difference between the Imports(as % of merchandise exports) in Middle East & North Africa (developing only) and Imports(as % of merchandise exports) in Iceland?
Offer a very short reply. -20.3. In the year 2000, what is the difference between the Imports(as % of merchandise exports) in Middle East & North Africa (developing only) and Imports(as % of merchandise exports) in Philippines?
Your response must be concise. -19.89. In the year 2000, what is the difference between the Imports(as % of merchandise exports) in Middle East & North Africa (developing only) and Imports(as % of merchandise exports) in Qatar?
Make the answer very short. -26.29. In the year 2000, what is the difference between the Imports(as % of merchandise exports) in Iceland and Imports(as % of merchandise exports) in Philippines?
Offer a very short reply. 0.41. In the year 2000, what is the difference between the Imports(as % of merchandise exports) in Iceland and Imports(as % of merchandise exports) in Qatar?
Your answer should be very brief. -5.98. In the year 2000, what is the difference between the Imports(as % of merchandise exports) in Philippines and Imports(as % of merchandise exports) in Qatar?
Offer a terse response. -6.39. In the year 2001, what is the difference between the Imports(as % of merchandise exports) in Middle East & North Africa (developing only) and Imports(as % of merchandise exports) in Iceland?
Your answer should be compact. -19.44. In the year 2001, what is the difference between the Imports(as % of merchandise exports) of Middle East & North Africa (developing only) and Imports(as % of merchandise exports) of Philippines?
Your response must be concise. -19.96. In the year 2001, what is the difference between the Imports(as % of merchandise exports) in Middle East & North Africa (developing only) and Imports(as % of merchandise exports) in Qatar?
Offer a terse response. -26.75. In the year 2001, what is the difference between the Imports(as % of merchandise exports) in Iceland and Imports(as % of merchandise exports) in Philippines?
Keep it short and to the point. -0.52. In the year 2001, what is the difference between the Imports(as % of merchandise exports) of Iceland and Imports(as % of merchandise exports) of Qatar?
Provide a short and direct response. -7.31. In the year 2001, what is the difference between the Imports(as % of merchandise exports) in Philippines and Imports(as % of merchandise exports) in Qatar?
Give a very brief answer. -6.79. In the year 2002, what is the difference between the Imports(as % of merchandise exports) in Middle East & North Africa (developing only) and Imports(as % of merchandise exports) in Iceland?
Your answer should be very brief. -12.78. In the year 2002, what is the difference between the Imports(as % of merchandise exports) in Middle East & North Africa (developing only) and Imports(as % of merchandise exports) in Philippines?
Provide a short and direct response. -18.9. In the year 2002, what is the difference between the Imports(as % of merchandise exports) of Middle East & North Africa (developing only) and Imports(as % of merchandise exports) of Qatar?
Your answer should be very brief. -21.26. In the year 2002, what is the difference between the Imports(as % of merchandise exports) in Iceland and Imports(as % of merchandise exports) in Philippines?
Offer a very short reply. -6.12. In the year 2002, what is the difference between the Imports(as % of merchandise exports) in Iceland and Imports(as % of merchandise exports) in Qatar?
Provide a succinct answer. -8.47. In the year 2002, what is the difference between the Imports(as % of merchandise exports) in Philippines and Imports(as % of merchandise exports) in Qatar?
Your response must be concise. -2.36. In the year 2003, what is the difference between the Imports(as % of merchandise exports) of Middle East & North Africa (developing only) and Imports(as % of merchandise exports) of Iceland?
Offer a very short reply. -10.81. In the year 2003, what is the difference between the Imports(as % of merchandise exports) of Middle East & North Africa (developing only) and Imports(as % of merchandise exports) of Philippines?
Give a very brief answer. -13.93. In the year 2003, what is the difference between the Imports(as % of merchandise exports) in Middle East & North Africa (developing only) and Imports(as % of merchandise exports) in Qatar?
Offer a terse response. -18.59. In the year 2003, what is the difference between the Imports(as % of merchandise exports) of Iceland and Imports(as % of merchandise exports) of Philippines?
Provide a succinct answer. -3.12. In the year 2003, what is the difference between the Imports(as % of merchandise exports) in Iceland and Imports(as % of merchandise exports) in Qatar?
Your answer should be compact. -7.77. In the year 2003, what is the difference between the Imports(as % of merchandise exports) in Philippines and Imports(as % of merchandise exports) in Qatar?
Your response must be concise. -4.66. In the year 2004, what is the difference between the Imports(as % of merchandise exports) in Middle East & North Africa (developing only) and Imports(as % of merchandise exports) in Iceland?
Your answer should be compact. -11.38. In the year 2004, what is the difference between the Imports(as % of merchandise exports) in Middle East & North Africa (developing only) and Imports(as % of merchandise exports) in Philippines?
Provide a succinct answer. -12.9. In the year 2004, what is the difference between the Imports(as % of merchandise exports) of Middle East & North Africa (developing only) and Imports(as % of merchandise exports) of Qatar?
Provide a succinct answer. -22.54. In the year 2004, what is the difference between the Imports(as % of merchandise exports) in Iceland and Imports(as % of merchandise exports) in Philippines?
Provide a succinct answer. -1.52. In the year 2004, what is the difference between the Imports(as % of merchandise exports) of Iceland and Imports(as % of merchandise exports) of Qatar?
Your answer should be compact. -11.17. In the year 2004, what is the difference between the Imports(as % of merchandise exports) in Philippines and Imports(as % of merchandise exports) in Qatar?
Make the answer very short. -9.65. In the year 2005, what is the difference between the Imports(as % of merchandise exports) of Middle East & North Africa (developing only) and Imports(as % of merchandise exports) of Iceland?
Your response must be concise. -15.41. In the year 2005, what is the difference between the Imports(as % of merchandise exports) of Middle East & North Africa (developing only) and Imports(as % of merchandise exports) of Philippines?
Keep it short and to the point. -12.48. In the year 2005, what is the difference between the Imports(as % of merchandise exports) of Middle East & North Africa (developing only) and Imports(as % of merchandise exports) of Qatar?
Provide a succinct answer. -25.19. In the year 2005, what is the difference between the Imports(as % of merchandise exports) of Iceland and Imports(as % of merchandise exports) of Philippines?
Offer a terse response. 2.93. In the year 2005, what is the difference between the Imports(as % of merchandise exports) of Iceland and Imports(as % of merchandise exports) of Qatar?
Your response must be concise. -9.77. In the year 2005, what is the difference between the Imports(as % of merchandise exports) of Philippines and Imports(as % of merchandise exports) of Qatar?
Make the answer very short. -12.71. In the year 2006, what is the difference between the Imports(as % of merchandise exports) of Middle East & North Africa (developing only) and Imports(as % of merchandise exports) of Iceland?
Provide a short and direct response. -32.51. In the year 2006, what is the difference between the Imports(as % of merchandise exports) of Middle East & North Africa (developing only) and Imports(as % of merchandise exports) of Philippines?
Give a very brief answer. -26.35. In the year 2006, what is the difference between the Imports(as % of merchandise exports) in Middle East & North Africa (developing only) and Imports(as % of merchandise exports) in Qatar?
Give a very brief answer. -34.96. In the year 2006, what is the difference between the Imports(as % of merchandise exports) of Iceland and Imports(as % of merchandise exports) of Philippines?
Make the answer very short. 6.16. In the year 2006, what is the difference between the Imports(as % of merchandise exports) of Iceland and Imports(as % of merchandise exports) of Qatar?
Provide a short and direct response. -2.45. In the year 2006, what is the difference between the Imports(as % of merchandise exports) of Philippines and Imports(as % of merchandise exports) of Qatar?
Your answer should be very brief. -8.61. What is the ratio of the Imports(as % of merchandise exports) of Middle East & North Africa (developing only) in 1999 to that in 2000?
Give a very brief answer. 1.15. What is the ratio of the Imports(as % of merchandise exports) in Iceland in 1999 to that in 2000?
Make the answer very short. 1.04. What is the ratio of the Imports(as % of merchandise exports) in Philippines in 1999 to that in 2000?
Ensure brevity in your answer.  1.02. What is the ratio of the Imports(as % of merchandise exports) in Qatar in 1999 to that in 2000?
Your answer should be very brief. 0.95. What is the ratio of the Imports(as % of merchandise exports) of Middle East & North Africa (developing only) in 1999 to that in 2001?
Make the answer very short. 1.15. What is the ratio of the Imports(as % of merchandise exports) of Iceland in 1999 to that in 2001?
Ensure brevity in your answer.  1.05. What is the ratio of the Imports(as % of merchandise exports) of Philippines in 1999 to that in 2001?
Keep it short and to the point. 1.01. What is the ratio of the Imports(as % of merchandise exports) in Qatar in 1999 to that in 2001?
Give a very brief answer. 0.94. What is the ratio of the Imports(as % of merchandise exports) of Middle East & North Africa (developing only) in 1999 to that in 2002?
Keep it short and to the point. 1.07. What is the ratio of the Imports(as % of merchandise exports) in Iceland in 1999 to that in 2002?
Provide a short and direct response. 1.09. What is the ratio of the Imports(as % of merchandise exports) in Philippines in 1999 to that in 2002?
Provide a succinct answer. 0.97. What is the ratio of the Imports(as % of merchandise exports) in Qatar in 1999 to that in 2002?
Provide a short and direct response. 0.95. What is the ratio of the Imports(as % of merchandise exports) in Iceland in 1999 to that in 2003?
Give a very brief answer. 1.05. What is the ratio of the Imports(as % of merchandise exports) of Qatar in 1999 to that in 2003?
Make the answer very short. 0.93. What is the ratio of the Imports(as % of merchandise exports) of Middle East & North Africa (developing only) in 1999 to that in 2004?
Keep it short and to the point. 1.01. What is the ratio of the Imports(as % of merchandise exports) in Iceland in 1999 to that in 2004?
Provide a short and direct response. 1.06. What is the ratio of the Imports(as % of merchandise exports) of Philippines in 1999 to that in 2004?
Offer a very short reply. 1. What is the ratio of the Imports(as % of merchandise exports) of Qatar in 1999 to that in 2004?
Your answer should be compact. 0.9. What is the ratio of the Imports(as % of merchandise exports) in Middle East & North Africa (developing only) in 1999 to that in 2005?
Provide a succinct answer. 1.05. What is the ratio of the Imports(as % of merchandise exports) of Iceland in 1999 to that in 2005?
Your answer should be very brief. 1.03. What is the ratio of the Imports(as % of merchandise exports) in Philippines in 1999 to that in 2005?
Provide a short and direct response. 1.03. What is the ratio of the Imports(as % of merchandise exports) in Qatar in 1999 to that in 2005?
Your answer should be compact. 0.9. What is the ratio of the Imports(as % of merchandise exports) of Middle East & North Africa (developing only) in 1999 to that in 2006?
Keep it short and to the point. 1.39. What is the ratio of the Imports(as % of merchandise exports) of Iceland in 1999 to that in 2006?
Make the answer very short. 1.01. What is the ratio of the Imports(as % of merchandise exports) in Philippines in 1999 to that in 2006?
Provide a short and direct response. 1.06. What is the ratio of the Imports(as % of merchandise exports) of Qatar in 1999 to that in 2006?
Your answer should be very brief. 0.96. What is the ratio of the Imports(as % of merchandise exports) in Middle East & North Africa (developing only) in 2000 to that in 2001?
Your response must be concise. 1. What is the ratio of the Imports(as % of merchandise exports) of Iceland in 2000 to that in 2001?
Keep it short and to the point. 1.01. What is the ratio of the Imports(as % of merchandise exports) in Philippines in 2000 to that in 2001?
Provide a succinct answer. 1. What is the ratio of the Imports(as % of merchandise exports) in Middle East & North Africa (developing only) in 2000 to that in 2002?
Provide a short and direct response. 0.93. What is the ratio of the Imports(as % of merchandise exports) of Iceland in 2000 to that in 2002?
Ensure brevity in your answer.  1.04. What is the ratio of the Imports(as % of merchandise exports) of Philippines in 2000 to that in 2002?
Your response must be concise. 0.96. What is the ratio of the Imports(as % of merchandise exports) of Qatar in 2000 to that in 2002?
Offer a terse response. 1.01. What is the ratio of the Imports(as % of merchandise exports) of Middle East & North Africa (developing only) in 2000 to that in 2003?
Give a very brief answer. 0.87. What is the ratio of the Imports(as % of merchandise exports) in Iceland in 2000 to that in 2003?
Keep it short and to the point. 1.01. What is the ratio of the Imports(as % of merchandise exports) in Philippines in 2000 to that in 2003?
Make the answer very short. 0.96. What is the ratio of the Imports(as % of merchandise exports) in Qatar in 2000 to that in 2003?
Ensure brevity in your answer.  0.99. What is the ratio of the Imports(as % of merchandise exports) of Middle East & North Africa (developing only) in 2000 to that in 2004?
Keep it short and to the point. 0.88. What is the ratio of the Imports(as % of merchandise exports) in Iceland in 2000 to that in 2004?
Keep it short and to the point. 1.01. What is the ratio of the Imports(as % of merchandise exports) of Philippines in 2000 to that in 2004?
Keep it short and to the point. 0.99. What is the ratio of the Imports(as % of merchandise exports) in Qatar in 2000 to that in 2004?
Keep it short and to the point. 0.95. What is the ratio of the Imports(as % of merchandise exports) in Middle East & North Africa (developing only) in 2000 to that in 2005?
Give a very brief answer. 0.91. What is the ratio of the Imports(as % of merchandise exports) of Iceland in 2000 to that in 2005?
Provide a short and direct response. 0.99. What is the ratio of the Imports(as % of merchandise exports) of Qatar in 2000 to that in 2005?
Ensure brevity in your answer.  0.95. What is the ratio of the Imports(as % of merchandise exports) in Middle East & North Africa (developing only) in 2000 to that in 2006?
Your answer should be compact. 1.2. What is the ratio of the Imports(as % of merchandise exports) of Iceland in 2000 to that in 2006?
Your answer should be compact. 0.97. What is the ratio of the Imports(as % of merchandise exports) in Philippines in 2000 to that in 2006?
Keep it short and to the point. 1.05. What is the ratio of the Imports(as % of merchandise exports) in Qatar in 2000 to that in 2006?
Make the answer very short. 1.01. What is the ratio of the Imports(as % of merchandise exports) in Middle East & North Africa (developing only) in 2001 to that in 2002?
Keep it short and to the point. 0.93. What is the ratio of the Imports(as % of merchandise exports) of Iceland in 2001 to that in 2002?
Your response must be concise. 1.03. What is the ratio of the Imports(as % of merchandise exports) of Philippines in 2001 to that in 2002?
Provide a succinct answer. 0.96. What is the ratio of the Imports(as % of merchandise exports) of Qatar in 2001 to that in 2002?
Your answer should be compact. 1.01. What is the ratio of the Imports(as % of merchandise exports) of Middle East & North Africa (developing only) in 2001 to that in 2003?
Your answer should be compact. 0.87. What is the ratio of the Imports(as % of merchandise exports) of Iceland in 2001 to that in 2003?
Provide a succinct answer. 1. What is the ratio of the Imports(as % of merchandise exports) of Philippines in 2001 to that in 2003?
Provide a short and direct response. 0.97. What is the ratio of the Imports(as % of merchandise exports) of Qatar in 2001 to that in 2003?
Provide a succinct answer. 0.99. What is the ratio of the Imports(as % of merchandise exports) of Middle East & North Africa (developing only) in 2001 to that in 2004?
Your answer should be compact. 0.88. What is the ratio of the Imports(as % of merchandise exports) in Iceland in 2001 to that in 2004?
Your answer should be compact. 1. What is the ratio of the Imports(as % of merchandise exports) of Philippines in 2001 to that in 2004?
Ensure brevity in your answer.  0.99. What is the ratio of the Imports(as % of merchandise exports) in Qatar in 2001 to that in 2004?
Your response must be concise. 0.96. What is the ratio of the Imports(as % of merchandise exports) in Middle East & North Africa (developing only) in 2001 to that in 2005?
Keep it short and to the point. 0.91. What is the ratio of the Imports(as % of merchandise exports) in Iceland in 2001 to that in 2005?
Your answer should be very brief. 0.98. What is the ratio of the Imports(as % of merchandise exports) in Philippines in 2001 to that in 2005?
Your response must be concise. 1.02. What is the ratio of the Imports(as % of merchandise exports) of Qatar in 2001 to that in 2005?
Your answer should be compact. 0.95. What is the ratio of the Imports(as % of merchandise exports) of Middle East & North Africa (developing only) in 2001 to that in 2006?
Offer a terse response. 1.21. What is the ratio of the Imports(as % of merchandise exports) of Iceland in 2001 to that in 2006?
Keep it short and to the point. 0.96. What is the ratio of the Imports(as % of merchandise exports) of Philippines in 2001 to that in 2006?
Offer a very short reply. 1.05. What is the ratio of the Imports(as % of merchandise exports) in Qatar in 2001 to that in 2006?
Make the answer very short. 1.02. What is the ratio of the Imports(as % of merchandise exports) of Middle East & North Africa (developing only) in 2002 to that in 2003?
Make the answer very short. 0.93. What is the ratio of the Imports(as % of merchandise exports) in Iceland in 2002 to that in 2003?
Keep it short and to the point. 0.97. What is the ratio of the Imports(as % of merchandise exports) in Philippines in 2002 to that in 2003?
Ensure brevity in your answer.  1.01. What is the ratio of the Imports(as % of merchandise exports) in Qatar in 2002 to that in 2003?
Provide a short and direct response. 0.98. What is the ratio of the Imports(as % of merchandise exports) of Middle East & North Africa (developing only) in 2002 to that in 2004?
Provide a short and direct response. 0.95. What is the ratio of the Imports(as % of merchandise exports) in Iceland in 2002 to that in 2004?
Offer a very short reply. 0.97. What is the ratio of the Imports(as % of merchandise exports) in Philippines in 2002 to that in 2004?
Offer a very short reply. 1.03. What is the ratio of the Imports(as % of merchandise exports) of Qatar in 2002 to that in 2004?
Provide a short and direct response. 0.95. What is the ratio of the Imports(as % of merchandise exports) of Middle East & North Africa (developing only) in 2002 to that in 2005?
Make the answer very short. 0.98. What is the ratio of the Imports(as % of merchandise exports) in Iceland in 2002 to that in 2005?
Provide a short and direct response. 0.95. What is the ratio of the Imports(as % of merchandise exports) of Philippines in 2002 to that in 2005?
Your response must be concise. 1.07. What is the ratio of the Imports(as % of merchandise exports) in Qatar in 2002 to that in 2005?
Your answer should be compact. 0.94. What is the ratio of the Imports(as % of merchandise exports) of Middle East & North Africa (developing only) in 2002 to that in 2006?
Offer a very short reply. 1.3. What is the ratio of the Imports(as % of merchandise exports) in Iceland in 2002 to that in 2006?
Ensure brevity in your answer.  0.93. What is the ratio of the Imports(as % of merchandise exports) of Philippines in 2002 to that in 2006?
Your answer should be compact. 1.09. What is the ratio of the Imports(as % of merchandise exports) of Qatar in 2002 to that in 2006?
Provide a short and direct response. 1.01. What is the ratio of the Imports(as % of merchandise exports) of Middle East & North Africa (developing only) in 2003 to that in 2004?
Your answer should be compact. 1.01. What is the ratio of the Imports(as % of merchandise exports) in Philippines in 2003 to that in 2004?
Give a very brief answer. 1.02. What is the ratio of the Imports(as % of merchandise exports) in Qatar in 2003 to that in 2004?
Provide a succinct answer. 0.97. What is the ratio of the Imports(as % of merchandise exports) in Middle East & North Africa (developing only) in 2003 to that in 2005?
Keep it short and to the point. 1.05. What is the ratio of the Imports(as % of merchandise exports) of Iceland in 2003 to that in 2005?
Provide a short and direct response. 0.98. What is the ratio of the Imports(as % of merchandise exports) of Philippines in 2003 to that in 2005?
Your answer should be compact. 1.06. What is the ratio of the Imports(as % of merchandise exports) in Qatar in 2003 to that in 2005?
Keep it short and to the point. 0.96. What is the ratio of the Imports(as % of merchandise exports) in Middle East & North Africa (developing only) in 2003 to that in 2006?
Provide a succinct answer. 1.39. What is the ratio of the Imports(as % of merchandise exports) of Philippines in 2003 to that in 2006?
Make the answer very short. 1.09. What is the ratio of the Imports(as % of merchandise exports) in Qatar in 2003 to that in 2006?
Keep it short and to the point. 1.03. What is the ratio of the Imports(as % of merchandise exports) in Middle East & North Africa (developing only) in 2004 to that in 2005?
Your answer should be very brief. 1.03. What is the ratio of the Imports(as % of merchandise exports) in Iceland in 2004 to that in 2005?
Your answer should be very brief. 0.98. What is the ratio of the Imports(as % of merchandise exports) of Philippines in 2004 to that in 2005?
Your response must be concise. 1.03. What is the ratio of the Imports(as % of merchandise exports) in Qatar in 2004 to that in 2005?
Make the answer very short. 0.99. What is the ratio of the Imports(as % of merchandise exports) in Middle East & North Africa (developing only) in 2004 to that in 2006?
Make the answer very short. 1.37. What is the ratio of the Imports(as % of merchandise exports) of Iceland in 2004 to that in 2006?
Offer a terse response. 0.96. What is the ratio of the Imports(as % of merchandise exports) in Philippines in 2004 to that in 2006?
Provide a short and direct response. 1.06. What is the ratio of the Imports(as % of merchandise exports) of Qatar in 2004 to that in 2006?
Provide a succinct answer. 1.07. What is the ratio of the Imports(as % of merchandise exports) in Middle East & North Africa (developing only) in 2005 to that in 2006?
Offer a terse response. 1.33. What is the ratio of the Imports(as % of merchandise exports) of Iceland in 2005 to that in 2006?
Offer a very short reply. 0.98. What is the ratio of the Imports(as % of merchandise exports) in Philippines in 2005 to that in 2006?
Ensure brevity in your answer.  1.03. What is the ratio of the Imports(as % of merchandise exports) of Qatar in 2005 to that in 2006?
Provide a succinct answer. 1.07. What is the difference between the highest and the second highest Imports(as % of merchandise exports) in Middle East & North Africa (developing only)?
Ensure brevity in your answer.  0.02. What is the difference between the highest and the second highest Imports(as % of merchandise exports) of Iceland?
Ensure brevity in your answer.  1.16. What is the difference between the highest and the second highest Imports(as % of merchandise exports) in Philippines?
Offer a terse response. 0.59. What is the difference between the highest and the second highest Imports(as % of merchandise exports) of Qatar?
Your answer should be compact. 0.54. What is the difference between the highest and the lowest Imports(as % of merchandise exports) of Middle East & North Africa (developing only)?
Offer a very short reply. 18.82. What is the difference between the highest and the lowest Imports(as % of merchandise exports) of Iceland?
Keep it short and to the point. 6.47. What is the difference between the highest and the lowest Imports(as % of merchandise exports) in Philippines?
Give a very brief answer. 6.97. What is the difference between the highest and the lowest Imports(as % of merchandise exports) in Qatar?
Make the answer very short. 9.32. 